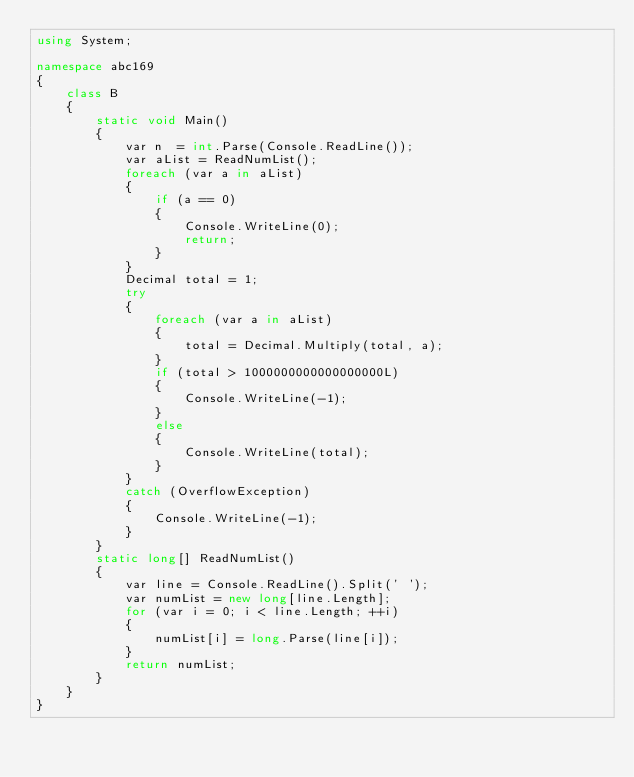Convert code to text. <code><loc_0><loc_0><loc_500><loc_500><_C#_>using System;

namespace abc169
{
    class B
    {
        static void Main()
        {
            var n  = int.Parse(Console.ReadLine());
            var aList = ReadNumList();
            foreach (var a in aList)
            {
                if (a == 0)
                {
                    Console.WriteLine(0);
                    return;
                }
            }
            Decimal total = 1;
            try
            {
                foreach (var a in aList)
                {
                    total = Decimal.Multiply(total, a);
                }
                if (total > 1000000000000000000L)
                {
                    Console.WriteLine(-1);
                }
                else
                {
                    Console.WriteLine(total);
                }
            }
            catch (OverflowException)
            {
                Console.WriteLine(-1);
            }
        }
        static long[] ReadNumList()
        {
            var line = Console.ReadLine().Split(' ');
            var numList = new long[line.Length];
            for (var i = 0; i < line.Length; ++i)
            {
                numList[i] = long.Parse(line[i]);
            }
            return numList;
        }
    }
}
</code> 